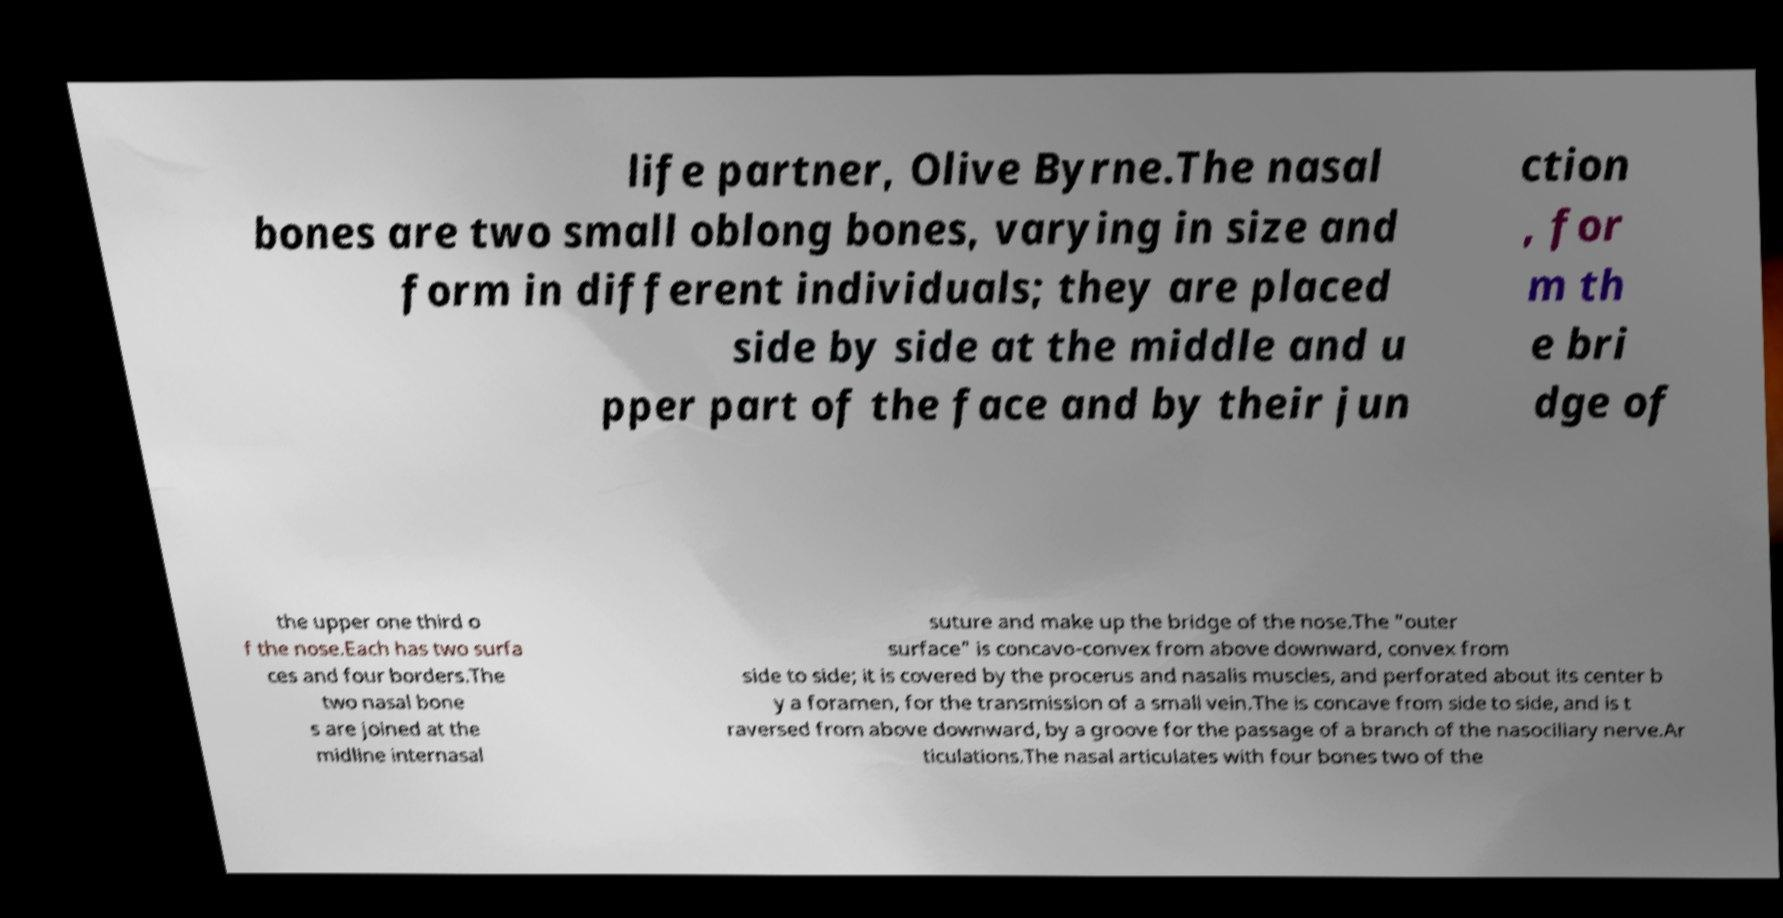Could you assist in decoding the text presented in this image and type it out clearly? life partner, Olive Byrne.The nasal bones are two small oblong bones, varying in size and form in different individuals; they are placed side by side at the middle and u pper part of the face and by their jun ction , for m th e bri dge of the upper one third o f the nose.Each has two surfa ces and four borders.The two nasal bone s are joined at the midline internasal suture and make up the bridge of the nose.The "outer surface" is concavo-convex from above downward, convex from side to side; it is covered by the procerus and nasalis muscles, and perforated about its center b y a foramen, for the transmission of a small vein.The is concave from side to side, and is t raversed from above downward, by a groove for the passage of a branch of the nasociliary nerve.Ar ticulations.The nasal articulates with four bones two of the 